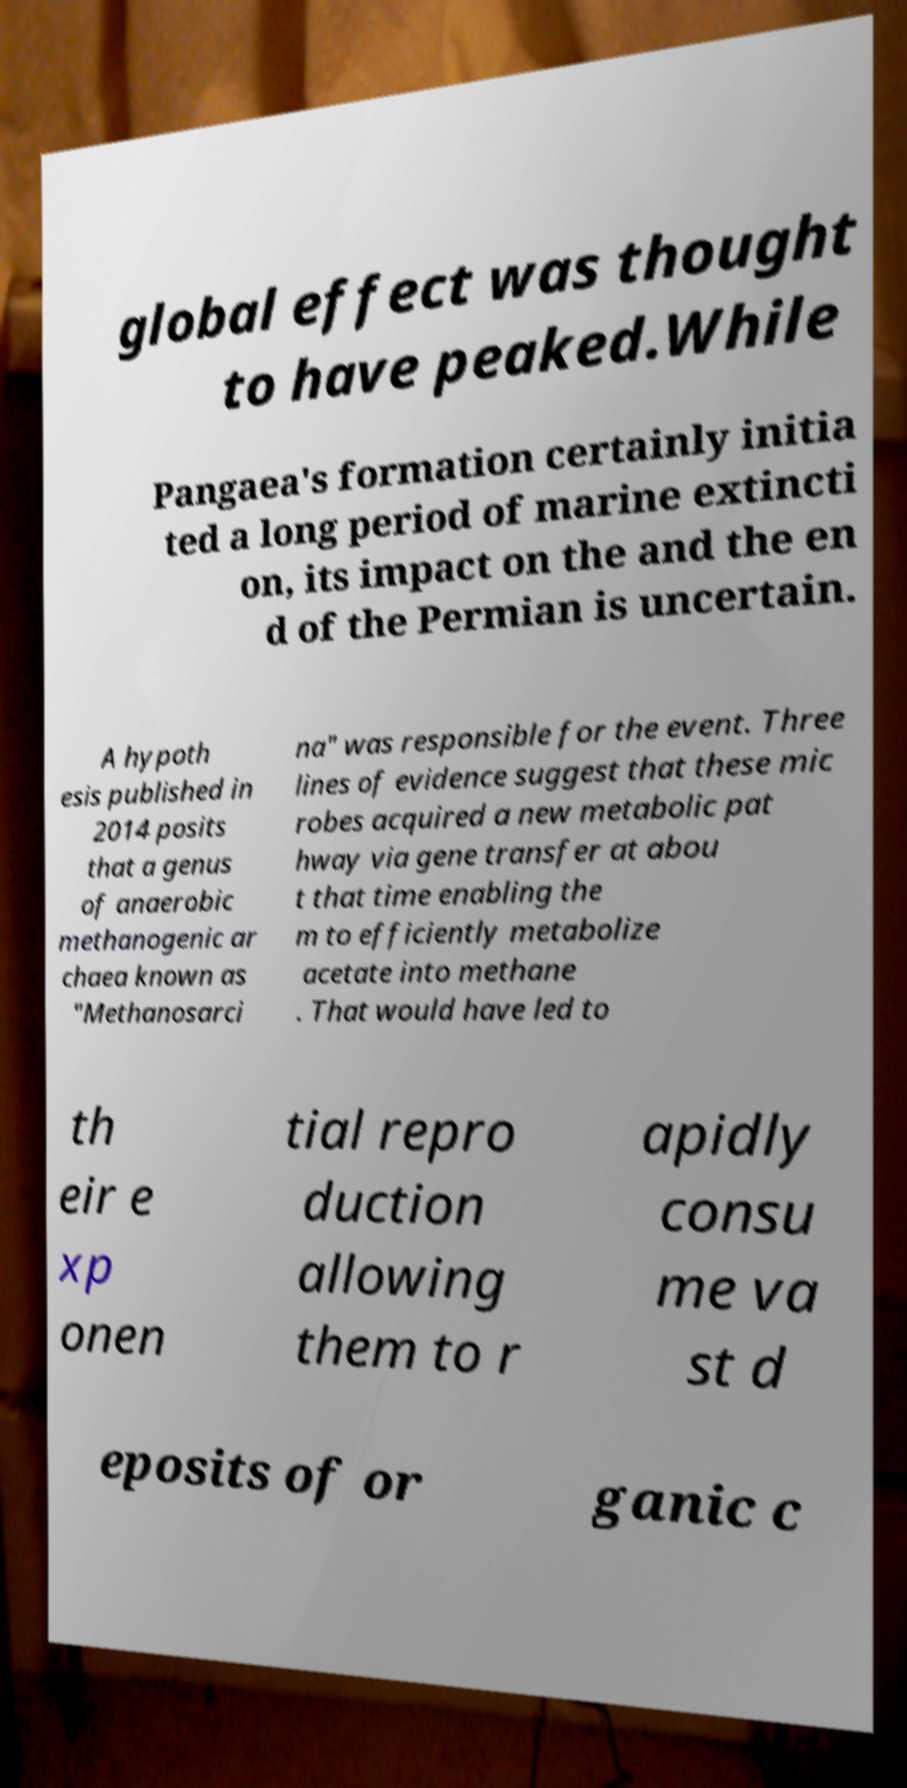For documentation purposes, I need the text within this image transcribed. Could you provide that? global effect was thought to have peaked.While Pangaea's formation certainly initia ted a long period of marine extincti on, its impact on the and the en d of the Permian is uncertain. A hypoth esis published in 2014 posits that a genus of anaerobic methanogenic ar chaea known as "Methanosarci na" was responsible for the event. Three lines of evidence suggest that these mic robes acquired a new metabolic pat hway via gene transfer at abou t that time enabling the m to efficiently metabolize acetate into methane . That would have led to th eir e xp onen tial repro duction allowing them to r apidly consu me va st d eposits of or ganic c 